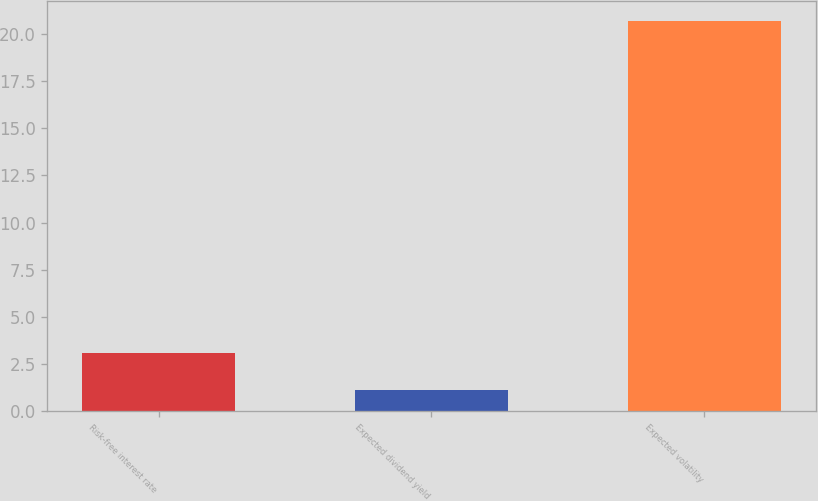Convert chart to OTSL. <chart><loc_0><loc_0><loc_500><loc_500><bar_chart><fcel>Risk-free interest rate<fcel>Expected dividend yield<fcel>Expected volatility<nl><fcel>3.08<fcel>1.12<fcel>20.68<nl></chart> 